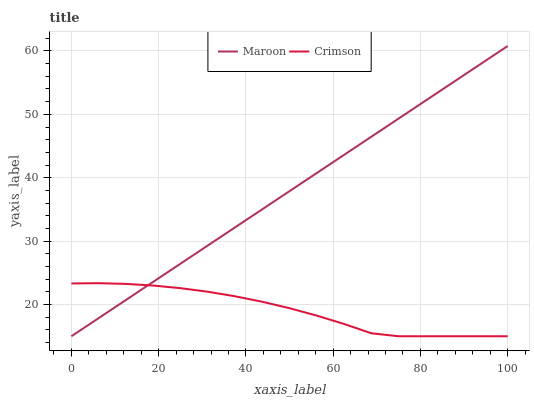Does Crimson have the minimum area under the curve?
Answer yes or no. Yes. Does Maroon have the maximum area under the curve?
Answer yes or no. Yes. Does Maroon have the minimum area under the curve?
Answer yes or no. No. Is Maroon the smoothest?
Answer yes or no. Yes. Is Crimson the roughest?
Answer yes or no. Yes. Is Maroon the roughest?
Answer yes or no. No. Does Maroon have the highest value?
Answer yes or no. Yes. Does Crimson intersect Maroon?
Answer yes or no. Yes. Is Crimson less than Maroon?
Answer yes or no. No. Is Crimson greater than Maroon?
Answer yes or no. No. 